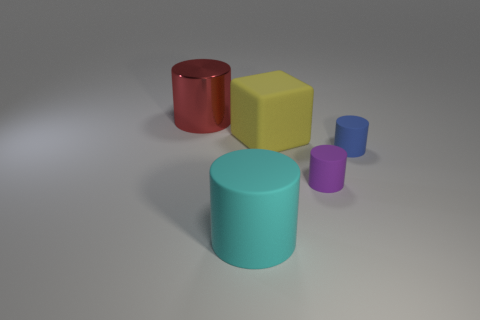What number of large cyan things have the same material as the small purple thing?
Offer a very short reply. 1. There is a cylinder that is behind the tiny matte object behind the tiny matte object that is on the left side of the blue rubber cylinder; what size is it?
Keep it short and to the point. Large. How many large yellow cubes are in front of the purple cylinder?
Your answer should be compact. 0. Are there more small purple objects than big green cylinders?
Your response must be concise. Yes. There is a cylinder that is both on the left side of the yellow thing and behind the cyan thing; what is its size?
Give a very brief answer. Large. What is the material of the large thing on the right side of the big object that is in front of the matte thing behind the blue matte cylinder?
Keep it short and to the point. Rubber. What shape is the thing behind the big thing on the right side of the big cylinder that is right of the big metallic cylinder?
Keep it short and to the point. Cylinder. What is the shape of the matte thing that is both on the left side of the purple matte thing and right of the large cyan thing?
Your response must be concise. Cube. There is a cylinder that is on the left side of the matte cylinder to the left of the yellow object; what number of large matte cubes are behind it?
Offer a very short reply. 0. There is a purple object that is the same shape as the small blue rubber thing; what is its size?
Your answer should be compact. Small. 